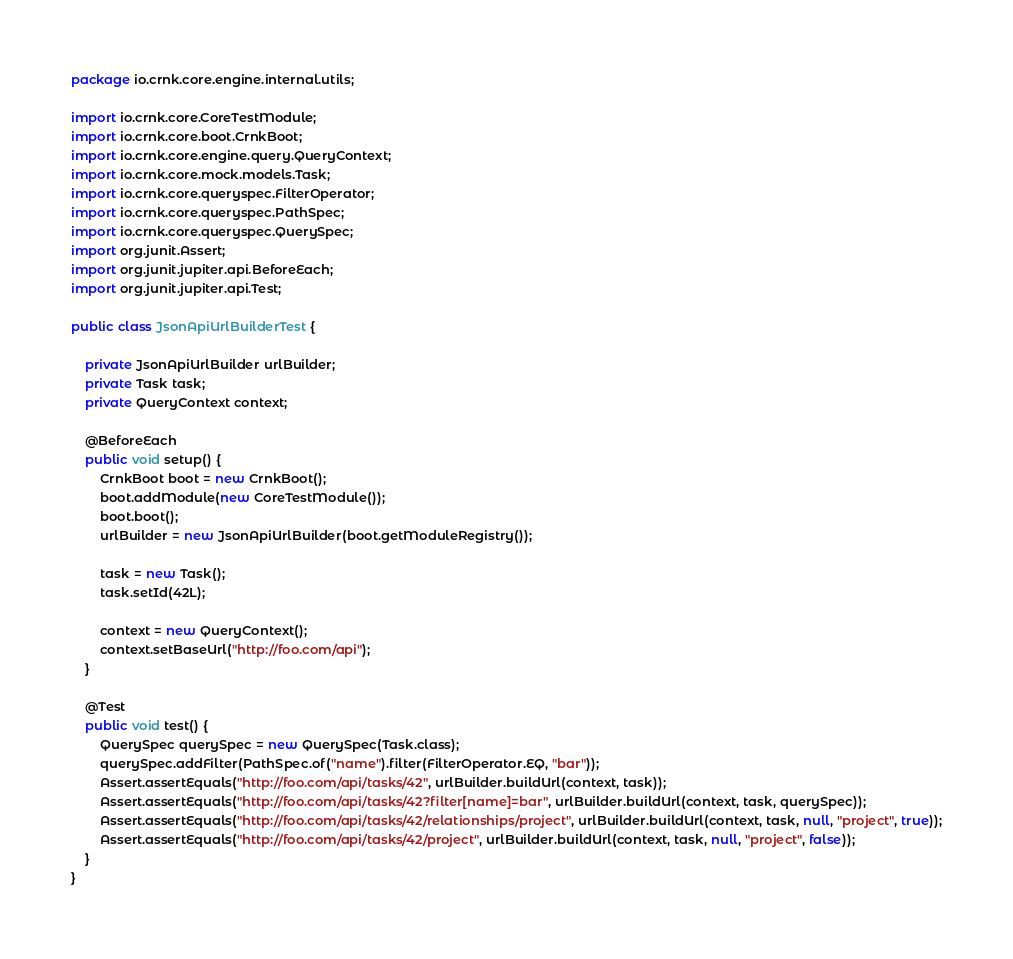<code> <loc_0><loc_0><loc_500><loc_500><_Java_>package io.crnk.core.engine.internal.utils;

import io.crnk.core.CoreTestModule;
import io.crnk.core.boot.CrnkBoot;
import io.crnk.core.engine.query.QueryContext;
import io.crnk.core.mock.models.Task;
import io.crnk.core.queryspec.FilterOperator;
import io.crnk.core.queryspec.PathSpec;
import io.crnk.core.queryspec.QuerySpec;
import org.junit.Assert;
import org.junit.jupiter.api.BeforeEach;
import org.junit.jupiter.api.Test;

public class JsonApiUrlBuilderTest {

	private JsonApiUrlBuilder urlBuilder;
	private Task task;
	private QueryContext context;

	@BeforeEach
	public void setup() {
		CrnkBoot boot = new CrnkBoot();
		boot.addModule(new CoreTestModule());
		boot.boot();
		urlBuilder = new JsonApiUrlBuilder(boot.getModuleRegistry());

		task = new Task();
		task.setId(42L);

		context = new QueryContext();
		context.setBaseUrl("http://foo.com/api");
	}

	@Test
	public void test() {
		QuerySpec querySpec = new QuerySpec(Task.class);
		querySpec.addFilter(PathSpec.of("name").filter(FilterOperator.EQ, "bar"));
		Assert.assertEquals("http://foo.com/api/tasks/42", urlBuilder.buildUrl(context, task));
		Assert.assertEquals("http://foo.com/api/tasks/42?filter[name]=bar", urlBuilder.buildUrl(context, task, querySpec));
		Assert.assertEquals("http://foo.com/api/tasks/42/relationships/project", urlBuilder.buildUrl(context, task, null, "project", true));
		Assert.assertEquals("http://foo.com/api/tasks/42/project", urlBuilder.buildUrl(context, task, null, "project", false));
	}
}
</code> 